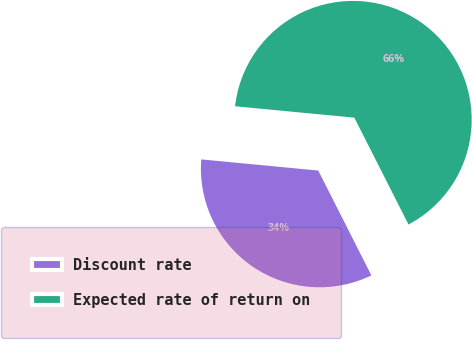<chart> <loc_0><loc_0><loc_500><loc_500><pie_chart><fcel>Discount rate<fcel>Expected rate of return on<nl><fcel>33.98%<fcel>66.02%<nl></chart> 